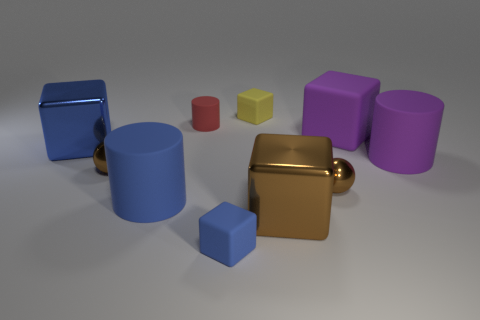How many things are to the left of the small metal sphere to the right of the small yellow rubber block?
Give a very brief answer. 7. There is a big cylinder that is on the left side of the matte cube that is in front of the purple rubber cube; are there any small blue matte cubes that are behind it?
Offer a very short reply. No. What material is the large blue thing that is the same shape as the tiny red matte object?
Ensure brevity in your answer.  Rubber. Is there anything else that is made of the same material as the small red thing?
Your answer should be compact. Yes. Does the large brown cube have the same material as the tiny block in front of the red matte thing?
Offer a terse response. No. What is the shape of the large thing behind the big metallic object that is on the left side of the small blue block?
Your answer should be compact. Cube. What number of tiny things are brown shiny cylinders or cylinders?
Your answer should be very brief. 1. How many brown things have the same shape as the tiny red rubber thing?
Your response must be concise. 0. Do the large brown shiny object and the big purple thing behind the purple cylinder have the same shape?
Your answer should be very brief. Yes. There is a small red rubber cylinder; what number of big cylinders are left of it?
Ensure brevity in your answer.  1. 